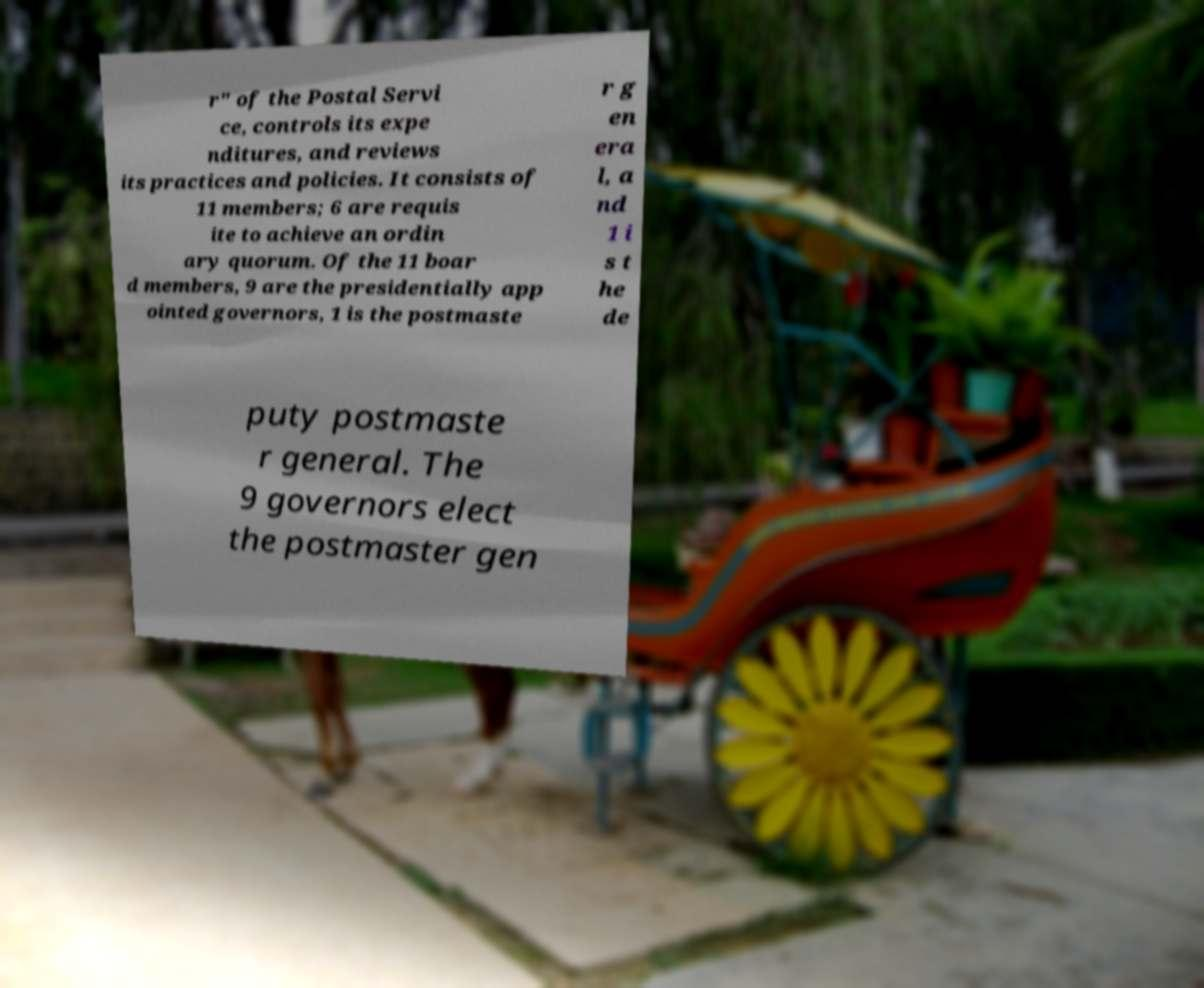Could you extract and type out the text from this image? r" of the Postal Servi ce, controls its expe nditures, and reviews its practices and policies. It consists of 11 members; 6 are requis ite to achieve an ordin ary quorum. Of the 11 boar d members, 9 are the presidentially app ointed governors, 1 is the postmaste r g en era l, a nd 1 i s t he de puty postmaste r general. The 9 governors elect the postmaster gen 